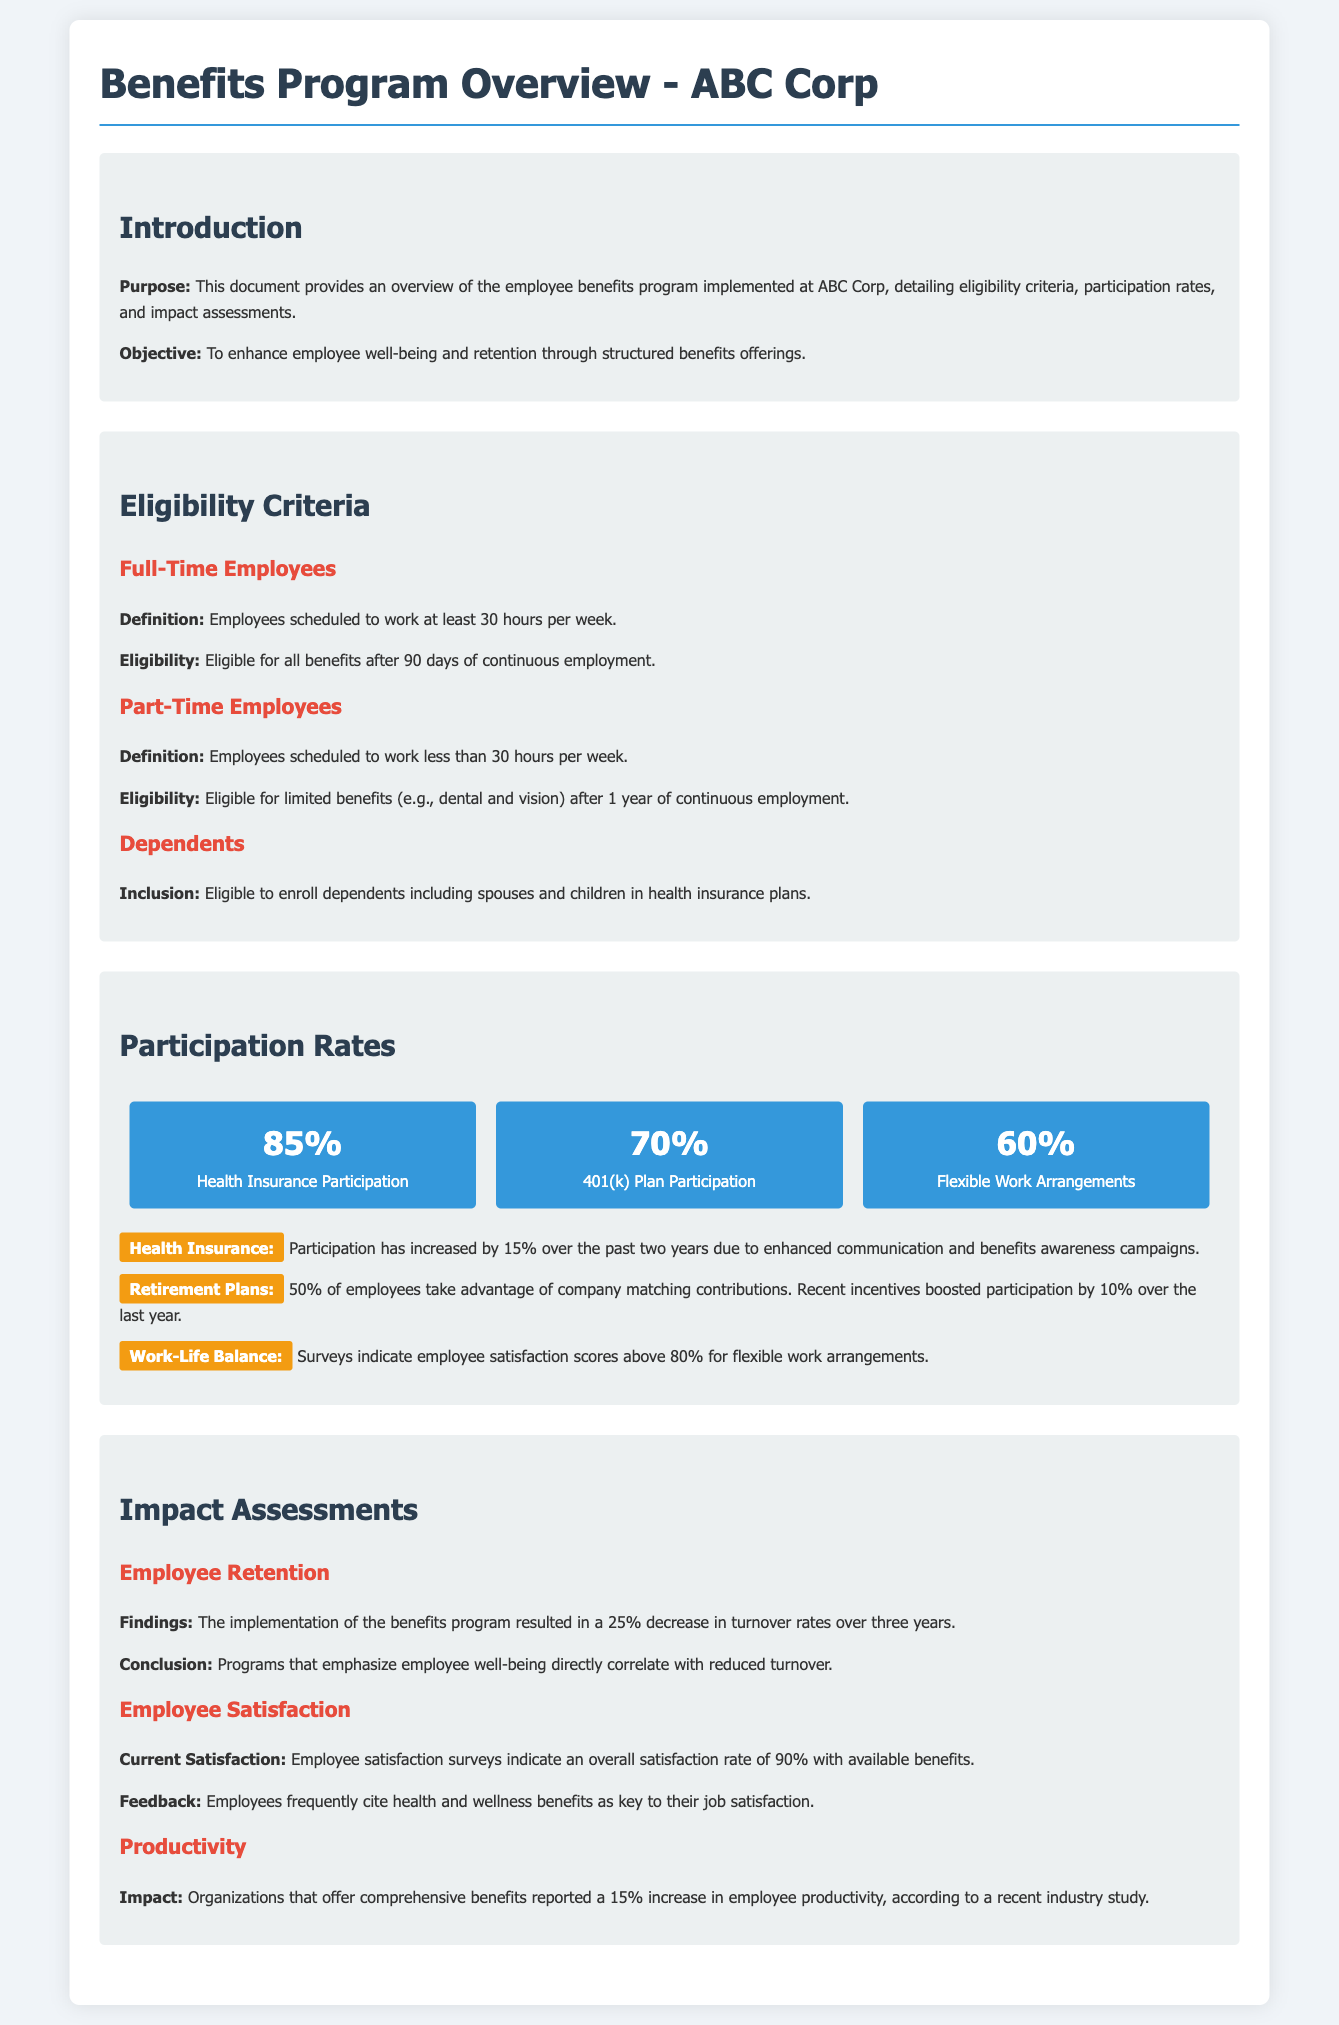What is the participation rate for Health Insurance? The document states that the participation rate for Health Insurance is 85%.
Answer: 85% What is the eligibility waiting period for full-time employees? Full-time employees are eligible for all benefits after 90 days of continuous employment.
Answer: 90 days What percentage of employees participate in the 401(k) Plan? The document indicates that 70% of employees participate in the 401(k) Plan.
Answer: 70% What is the increase in Health Insurance participation over the past two years? Health Insurance participation has increased by 15% over the past two years.
Answer: 15% What percentage decrease in turnover rates was observed due to the benefits program? The implementation of the benefits program resulted in a 25% decrease in turnover rates.
Answer: 25% What is the current employee satisfaction rate with benefits? Employee satisfaction surveys indicate an overall satisfaction rate of 90% with available benefits.
Answer: 90% What type of arrangements have a 60% participation rate? The document states that Flexible Work Arrangements have a 60% participation rate.
Answer: Flexible Work Arrangements What benefits are part-time employees eligible for after 1 year? Part-time employees are eligible for limited benefits (e.g., dental and vision) after 1 year of continuous employment.
Answer: Dental and vision What factor correlates with reduced turnover according to the findings? Programs that emphasize employee well-being directly correlate with reduced turnover.
Answer: Employee well-being 